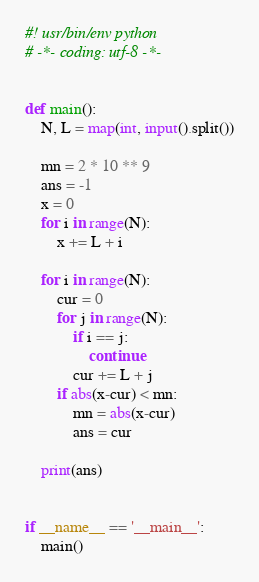<code> <loc_0><loc_0><loc_500><loc_500><_Python_>#! usr/bin/env python
# -*- coding: utf-8 -*-


def main():
    N, L = map(int, input().split())

    mn = 2 * 10 ** 9
    ans = -1
    x = 0
    for i in range(N):
        x += L + i

    for i in range(N):
        cur = 0
        for j in range(N):
            if i == j:
                continue
            cur += L + j
        if abs(x-cur) < mn:
            mn = abs(x-cur)
            ans = cur

    print(ans)


if __name__ == '__main__':
    main()
</code> 